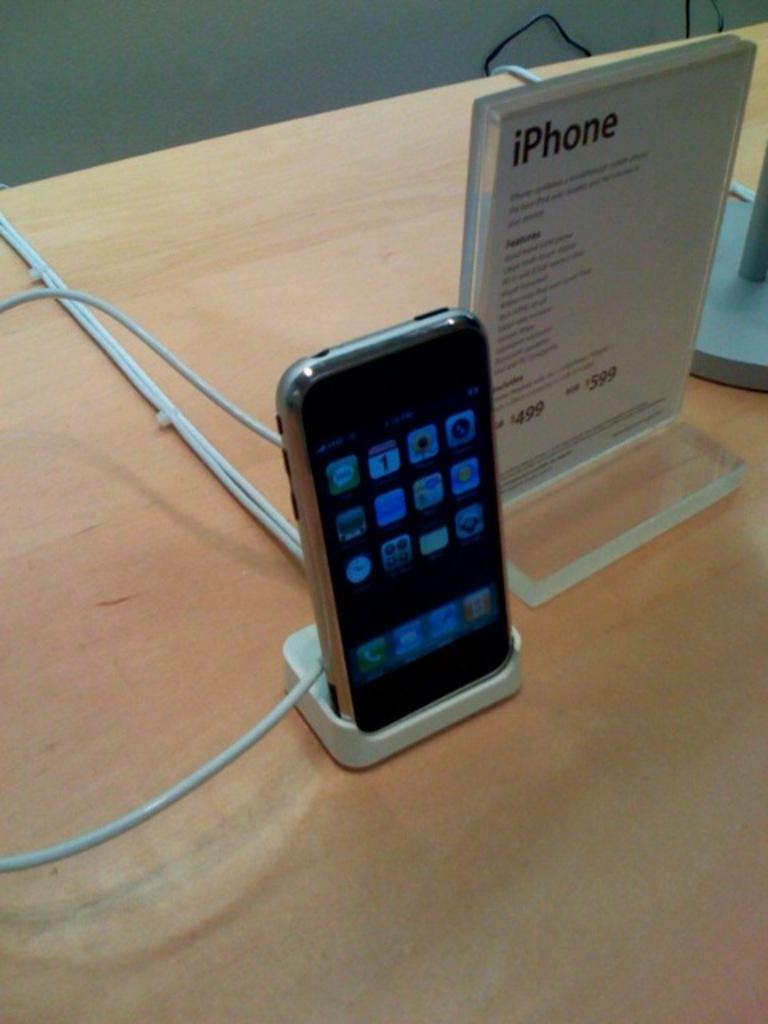What brand is the phone?
Provide a succinct answer. Iphone. What is this?
Your response must be concise. Iphone. 